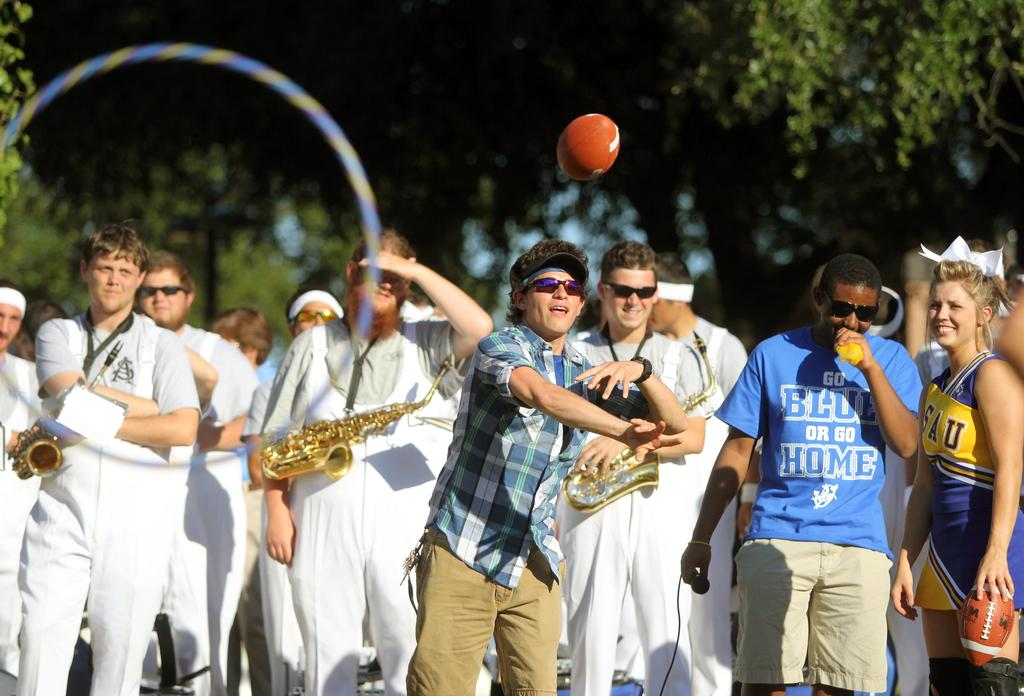Provide a one-sentence caption for the provided image. A black man in a go blue or go home shirt stands next to a person throwing a football. 